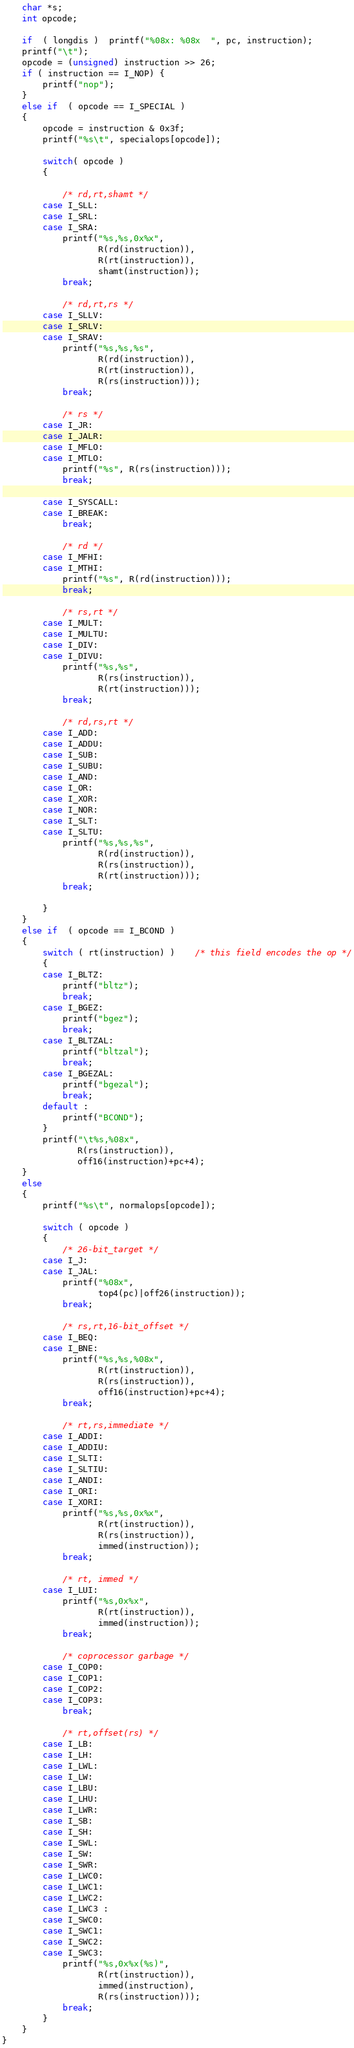<code> <loc_0><loc_0><loc_500><loc_500><_C_>    char *s;
    int opcode;

    if  ( longdis )  printf("%08x: %08x  ", pc, instruction);
    printf("\t");
    opcode = (unsigned) instruction >> 26;
    if ( instruction == I_NOP) {
        printf("nop");
    }
    else if  ( opcode == I_SPECIAL )
    {
        opcode = instruction & 0x3f;
        printf("%s\t", specialops[opcode]);

        switch( opcode )
        {

            /* rd,rt,shamt */
        case I_SLL:
        case I_SRL:
        case I_SRA:
            printf("%s,%s,0x%x",
                   R(rd(instruction)),
                   R(rt(instruction)),
                   shamt(instruction));
            break;

            /* rd,rt,rs */
        case I_SLLV:
        case I_SRLV:
        case I_SRAV:
            printf("%s,%s,%s",
                   R(rd(instruction)),
                   R(rt(instruction)),
                   R(rs(instruction)));
            break;

            /* rs */
        case I_JR:
        case I_JALR:
        case I_MFLO:
        case I_MTLO:
            printf("%s", R(rs(instruction)));
            break;

        case I_SYSCALL:
        case I_BREAK:
            break;

            /* rd */
        case I_MFHI:
        case I_MTHI:
            printf("%s", R(rd(instruction)));
            break;

            /* rs,rt */
        case I_MULT:
        case I_MULTU:
        case I_DIV:
        case I_DIVU:
            printf("%s,%s",
                   R(rs(instruction)),
                   R(rt(instruction)));
            break;

            /* rd,rs,rt */
        case I_ADD:
        case I_ADDU:
        case I_SUB:
        case I_SUBU:
        case I_AND:
        case I_OR:
        case I_XOR:
        case I_NOR:
        case I_SLT:
        case I_SLTU:
            printf("%s,%s,%s",
                   R(rd(instruction)),
                   R(rs(instruction)),
                   R(rt(instruction)));
            break;

        }
    }
    else if  ( opcode == I_BCOND )
    {
        switch ( rt(instruction) )	/* this field encodes the op */
        {
        case I_BLTZ:
            printf("bltz");
            break;
        case I_BGEZ:
            printf("bgez");
            break;
        case I_BLTZAL:
            printf("bltzal");
            break;
        case I_BGEZAL:
            printf("bgezal");
            break;
        default :
            printf("BCOND");
        }
        printf("\t%s,%08x",
               R(rs(instruction)),
               off16(instruction)+pc+4);
    }
    else
    {
        printf("%s\t", normalops[opcode]);

        switch ( opcode )
        {
            /* 26-bit_target */
        case I_J:
        case I_JAL:
            printf("%08x",
                   top4(pc)|off26(instruction));
            break;

            /* rs,rt,16-bit_offset */
        case I_BEQ:
        case I_BNE:
            printf("%s,%s,%08x",
                   R(rt(instruction)),
                   R(rs(instruction)),
                   off16(instruction)+pc+4);
            break;

            /* rt,rs,immediate */
        case I_ADDI:
        case I_ADDIU:
        case I_SLTI:
        case I_SLTIU:
        case I_ANDI:
        case I_ORI:
        case I_XORI:
            printf("%s,%s,0x%x",
                   R(rt(instruction)),
                   R(rs(instruction)),
                   immed(instruction));
            break;

            /* rt, immed */
        case I_LUI:
            printf("%s,0x%x",
                   R(rt(instruction)),
                   immed(instruction));
            break;

            /* coprocessor garbage */
        case I_COP0:
        case I_COP1:
        case I_COP2:
        case I_COP3:
            break;

            /* rt,offset(rs) */
        case I_LB:
        case I_LH:
        case I_LWL:
        case I_LW:
        case I_LBU:
        case I_LHU:
        case I_LWR:
        case I_SB:
        case I_SH:
        case I_SWL:
        case I_SW:
        case I_SWR:
        case I_LWC0:
        case I_LWC1:
        case I_LWC2:
        case I_LWC3 :
        case I_SWC0:
        case I_SWC1:
        case I_SWC2:
        case I_SWC3:
            printf("%s,0x%x(%s)",
                   R(rt(instruction)),
                   immed(instruction),
                   R(rs(instruction)));
            break;
        }
    }
}
</code> 